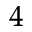<formula> <loc_0><loc_0><loc_500><loc_500>^ { 4 }</formula> 